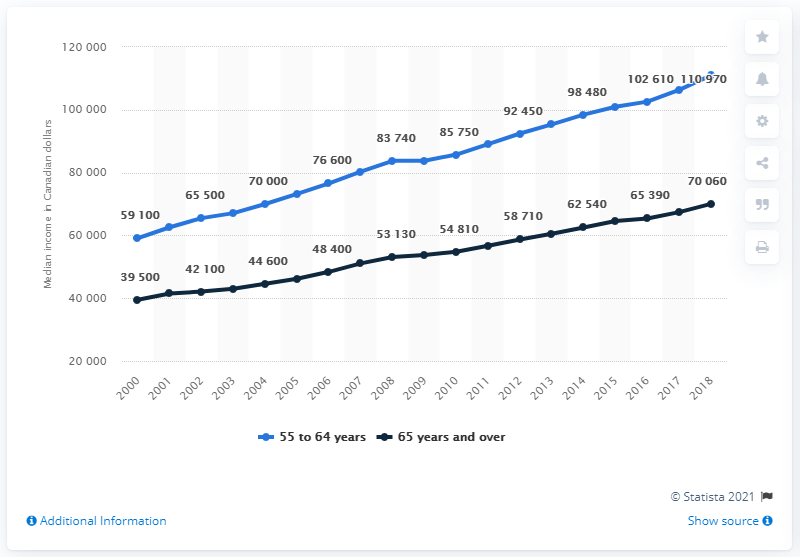Mention a couple of crucial points in this snapshot. The highest value of 55 to 64 years is 11,097 days. The smallest difference between the navy blue and blue lines is 19600. 